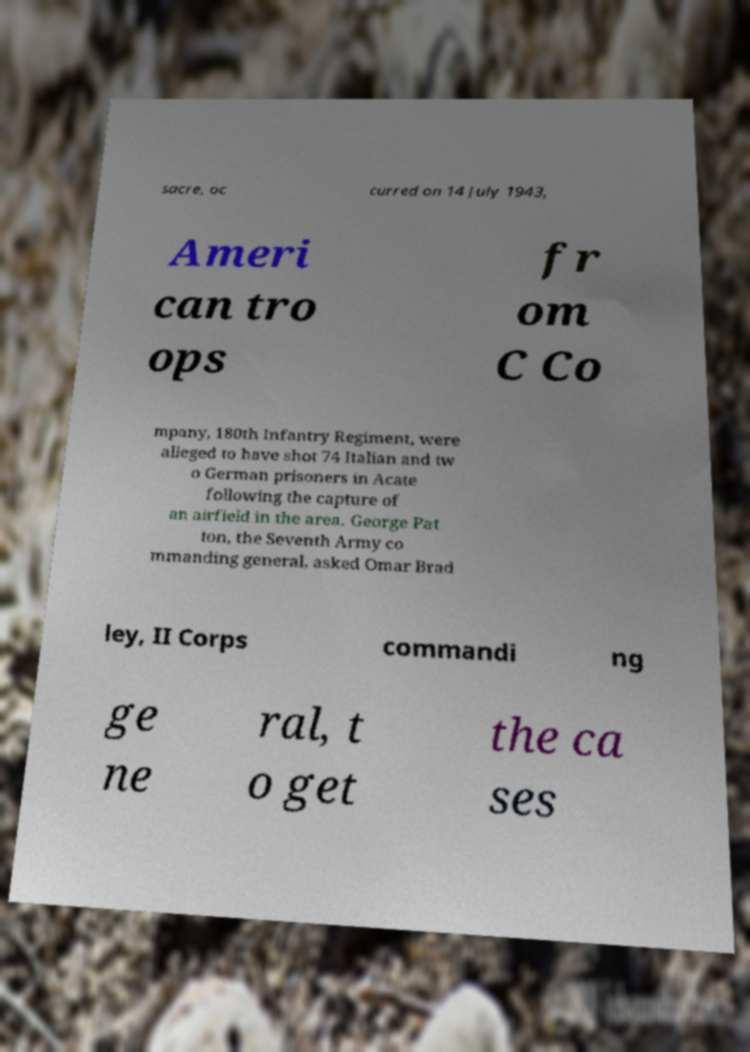Could you assist in decoding the text presented in this image and type it out clearly? sacre, oc curred on 14 July 1943, Ameri can tro ops fr om C Co mpany, 180th Infantry Regiment, were alleged to have shot 74 Italian and tw o German prisoners in Acate following the capture of an airfield in the area. George Pat ton, the Seventh Army co mmanding general, asked Omar Brad ley, II Corps commandi ng ge ne ral, t o get the ca ses 